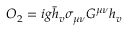Convert formula to latex. <formula><loc_0><loc_0><loc_500><loc_500>O _ { 2 } = i g \bar { h } _ { v } \sigma _ { \mu \nu } G ^ { \mu \nu } h _ { v }</formula> 